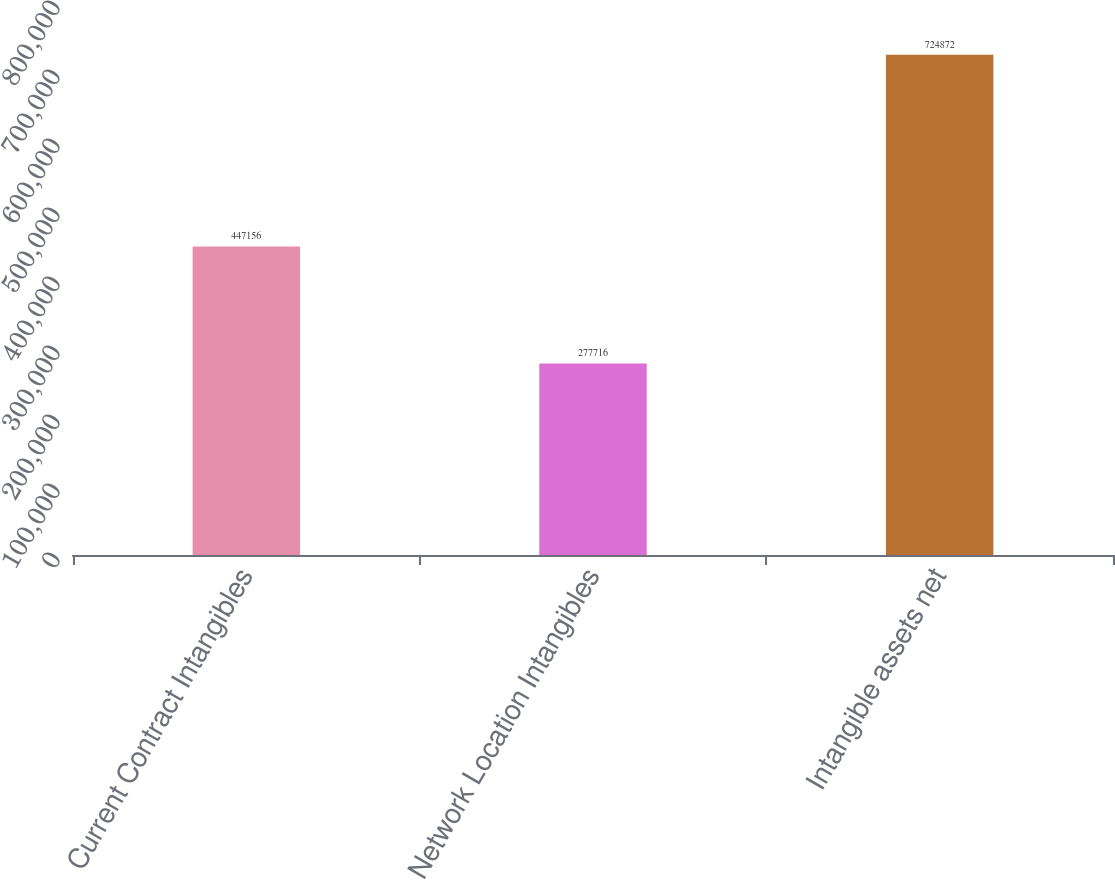<chart> <loc_0><loc_0><loc_500><loc_500><bar_chart><fcel>Current Contract Intangibles<fcel>Network Location Intangibles<fcel>Intangible assets net<nl><fcel>447156<fcel>277716<fcel>724872<nl></chart> 